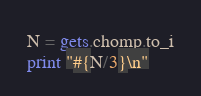Convert code to text. <code><loc_0><loc_0><loc_500><loc_500><_Ruby_>N = gets.chomp.to_i
print "#{N/3}\n"</code> 